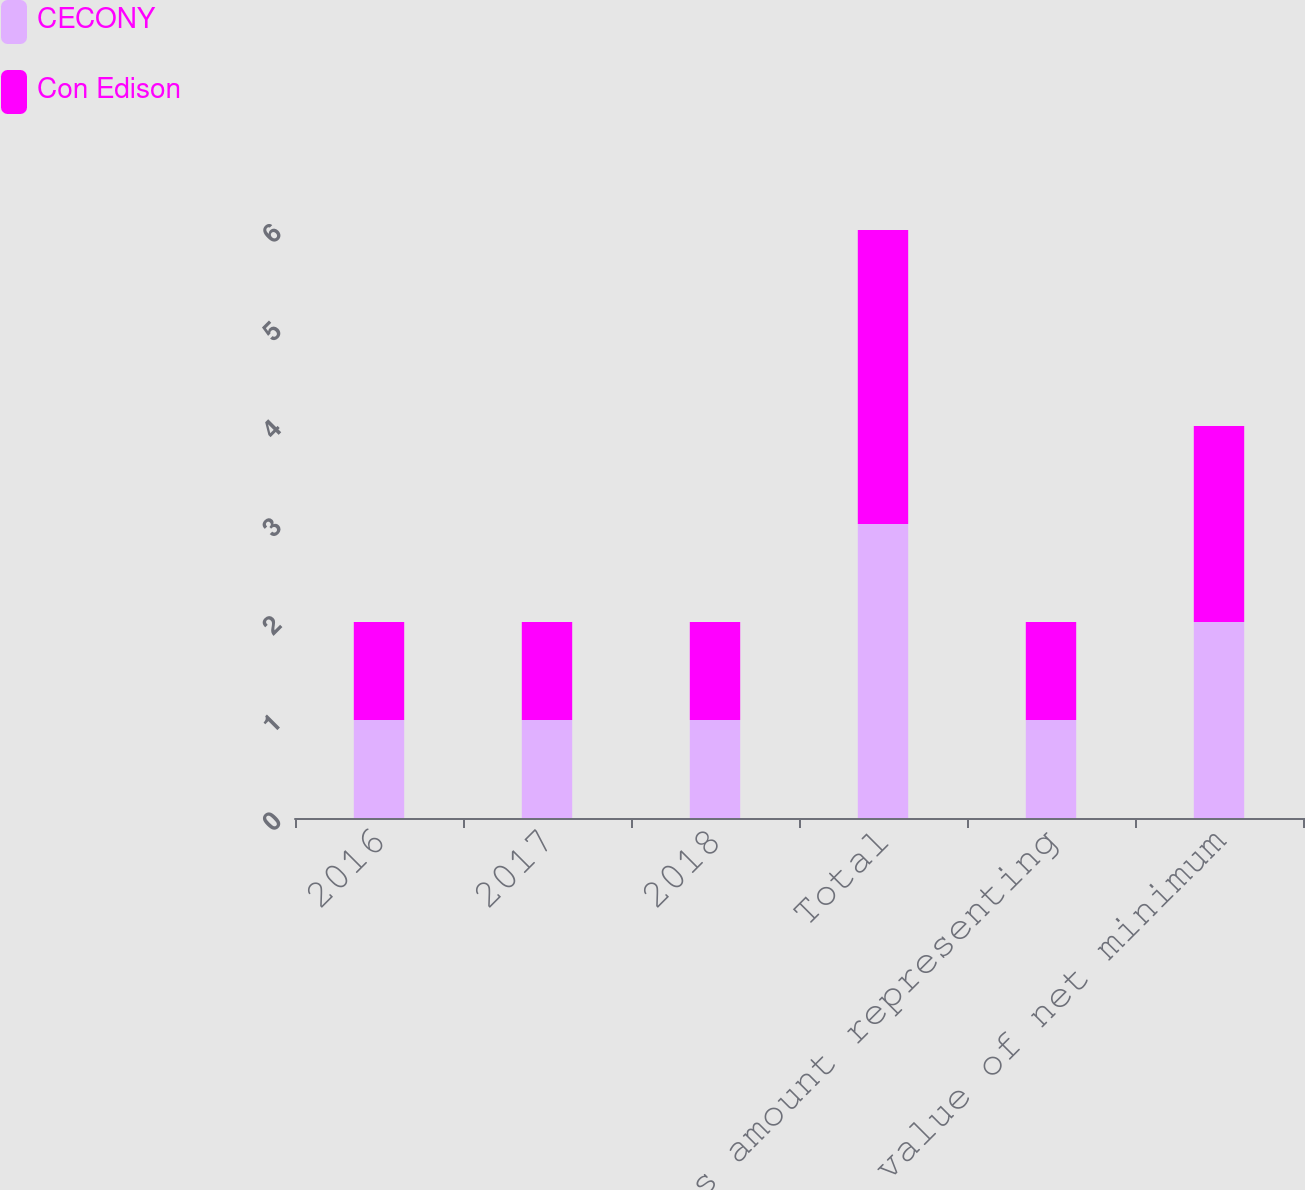Convert chart to OTSL. <chart><loc_0><loc_0><loc_500><loc_500><stacked_bar_chart><ecel><fcel>2016<fcel>2017<fcel>2018<fcel>Total<fcel>Less amount representing<fcel>Present value of net minimum<nl><fcel>CECONY<fcel>1<fcel>1<fcel>1<fcel>3<fcel>1<fcel>2<nl><fcel>Con Edison<fcel>1<fcel>1<fcel>1<fcel>3<fcel>1<fcel>2<nl></chart> 